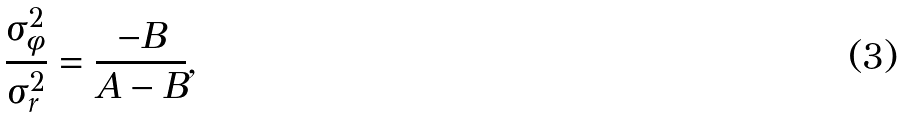<formula> <loc_0><loc_0><loc_500><loc_500>\frac { \sigma _ { \phi } ^ { 2 } } { \sigma _ { r } ^ { 2 } } = \frac { - B } { A - B } ,</formula> 